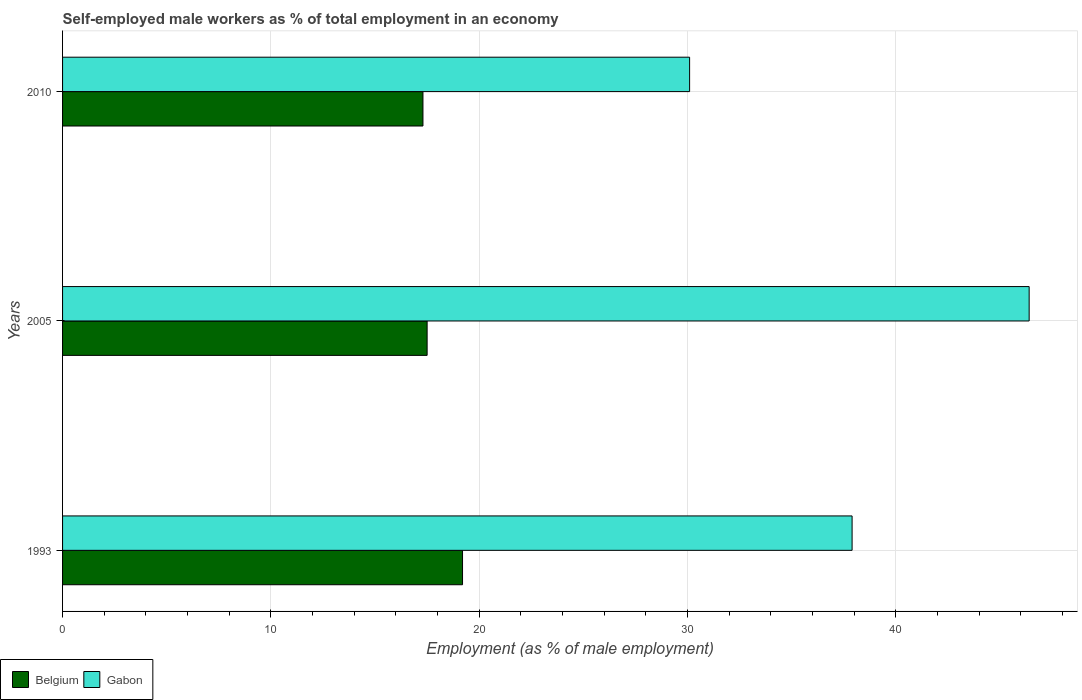Are the number of bars per tick equal to the number of legend labels?
Make the answer very short. Yes. Are the number of bars on each tick of the Y-axis equal?
Your answer should be compact. Yes. How many bars are there on the 3rd tick from the top?
Offer a very short reply. 2. What is the label of the 2nd group of bars from the top?
Provide a short and direct response. 2005. What is the percentage of self-employed male workers in Belgium in 2010?
Keep it short and to the point. 17.3. Across all years, what is the maximum percentage of self-employed male workers in Belgium?
Your answer should be very brief. 19.2. Across all years, what is the minimum percentage of self-employed male workers in Belgium?
Provide a short and direct response. 17.3. In which year was the percentage of self-employed male workers in Gabon maximum?
Make the answer very short. 2005. In which year was the percentage of self-employed male workers in Belgium minimum?
Make the answer very short. 2010. What is the total percentage of self-employed male workers in Gabon in the graph?
Provide a succinct answer. 114.4. What is the difference between the percentage of self-employed male workers in Gabon in 1993 and that in 2010?
Your answer should be compact. 7.8. What is the difference between the percentage of self-employed male workers in Belgium in 2005 and the percentage of self-employed male workers in Gabon in 1993?
Your response must be concise. -20.4. What is the average percentage of self-employed male workers in Gabon per year?
Offer a terse response. 38.13. In the year 1993, what is the difference between the percentage of self-employed male workers in Gabon and percentage of self-employed male workers in Belgium?
Offer a very short reply. 18.7. What is the ratio of the percentage of self-employed male workers in Gabon in 2005 to that in 2010?
Your answer should be compact. 1.54. What is the difference between the highest and the second highest percentage of self-employed male workers in Belgium?
Provide a short and direct response. 1.7. What is the difference between the highest and the lowest percentage of self-employed male workers in Belgium?
Your answer should be very brief. 1.9. What does the 1st bar from the top in 1993 represents?
Provide a succinct answer. Gabon. How many bars are there?
Keep it short and to the point. 6. Are the values on the major ticks of X-axis written in scientific E-notation?
Offer a terse response. No. Does the graph contain any zero values?
Your answer should be very brief. No. Does the graph contain grids?
Your answer should be compact. Yes. Where does the legend appear in the graph?
Give a very brief answer. Bottom left. What is the title of the graph?
Ensure brevity in your answer.  Self-employed male workers as % of total employment in an economy. Does "Afghanistan" appear as one of the legend labels in the graph?
Offer a very short reply. No. What is the label or title of the X-axis?
Keep it short and to the point. Employment (as % of male employment). What is the label or title of the Y-axis?
Provide a succinct answer. Years. What is the Employment (as % of male employment) in Belgium in 1993?
Offer a very short reply. 19.2. What is the Employment (as % of male employment) in Gabon in 1993?
Provide a succinct answer. 37.9. What is the Employment (as % of male employment) in Belgium in 2005?
Offer a terse response. 17.5. What is the Employment (as % of male employment) of Gabon in 2005?
Your answer should be compact. 46.4. What is the Employment (as % of male employment) in Belgium in 2010?
Offer a very short reply. 17.3. What is the Employment (as % of male employment) of Gabon in 2010?
Give a very brief answer. 30.1. Across all years, what is the maximum Employment (as % of male employment) in Belgium?
Your answer should be very brief. 19.2. Across all years, what is the maximum Employment (as % of male employment) of Gabon?
Offer a very short reply. 46.4. Across all years, what is the minimum Employment (as % of male employment) in Belgium?
Your answer should be compact. 17.3. Across all years, what is the minimum Employment (as % of male employment) in Gabon?
Ensure brevity in your answer.  30.1. What is the total Employment (as % of male employment) of Gabon in the graph?
Give a very brief answer. 114.4. What is the difference between the Employment (as % of male employment) of Gabon in 1993 and that in 2005?
Provide a succinct answer. -8.5. What is the difference between the Employment (as % of male employment) of Belgium in 1993 and that in 2010?
Your answer should be compact. 1.9. What is the difference between the Employment (as % of male employment) in Belgium in 2005 and that in 2010?
Your answer should be very brief. 0.2. What is the difference between the Employment (as % of male employment) of Gabon in 2005 and that in 2010?
Keep it short and to the point. 16.3. What is the difference between the Employment (as % of male employment) of Belgium in 1993 and the Employment (as % of male employment) of Gabon in 2005?
Provide a short and direct response. -27.2. What is the difference between the Employment (as % of male employment) in Belgium in 1993 and the Employment (as % of male employment) in Gabon in 2010?
Provide a succinct answer. -10.9. What is the average Employment (as % of male employment) of Belgium per year?
Your response must be concise. 18. What is the average Employment (as % of male employment) in Gabon per year?
Your answer should be very brief. 38.13. In the year 1993, what is the difference between the Employment (as % of male employment) in Belgium and Employment (as % of male employment) in Gabon?
Provide a short and direct response. -18.7. In the year 2005, what is the difference between the Employment (as % of male employment) of Belgium and Employment (as % of male employment) of Gabon?
Offer a very short reply. -28.9. What is the ratio of the Employment (as % of male employment) in Belgium in 1993 to that in 2005?
Give a very brief answer. 1.1. What is the ratio of the Employment (as % of male employment) of Gabon in 1993 to that in 2005?
Offer a very short reply. 0.82. What is the ratio of the Employment (as % of male employment) in Belgium in 1993 to that in 2010?
Your answer should be very brief. 1.11. What is the ratio of the Employment (as % of male employment) in Gabon in 1993 to that in 2010?
Your response must be concise. 1.26. What is the ratio of the Employment (as % of male employment) of Belgium in 2005 to that in 2010?
Offer a very short reply. 1.01. What is the ratio of the Employment (as % of male employment) in Gabon in 2005 to that in 2010?
Provide a short and direct response. 1.54. What is the difference between the highest and the second highest Employment (as % of male employment) of Belgium?
Keep it short and to the point. 1.7. 